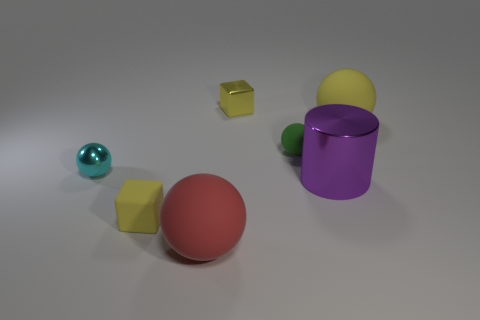Is the shape of the matte thing that is right of the cylinder the same as the big matte thing that is to the left of the tiny metallic cube?
Make the answer very short. Yes. What number of other things are the same size as the purple shiny thing?
Keep it short and to the point. 2. The purple thing is what size?
Offer a terse response. Large. Do the tiny block behind the yellow rubber block and the red sphere have the same material?
Your answer should be very brief. No. What color is the other tiny matte thing that is the same shape as the cyan thing?
Make the answer very short. Green. There is a small matte block that is left of the large yellow thing; is it the same color as the big cylinder?
Your response must be concise. No. Are there any small green balls to the left of the small rubber ball?
Your answer should be compact. No. The rubber object that is both right of the tiny yellow rubber block and in front of the cyan shiny object is what color?
Your response must be concise. Red. The small object that is the same color as the metallic block is what shape?
Ensure brevity in your answer.  Cube. There is a yellow block on the right side of the yellow object on the left side of the red matte sphere; what is its size?
Ensure brevity in your answer.  Small. 